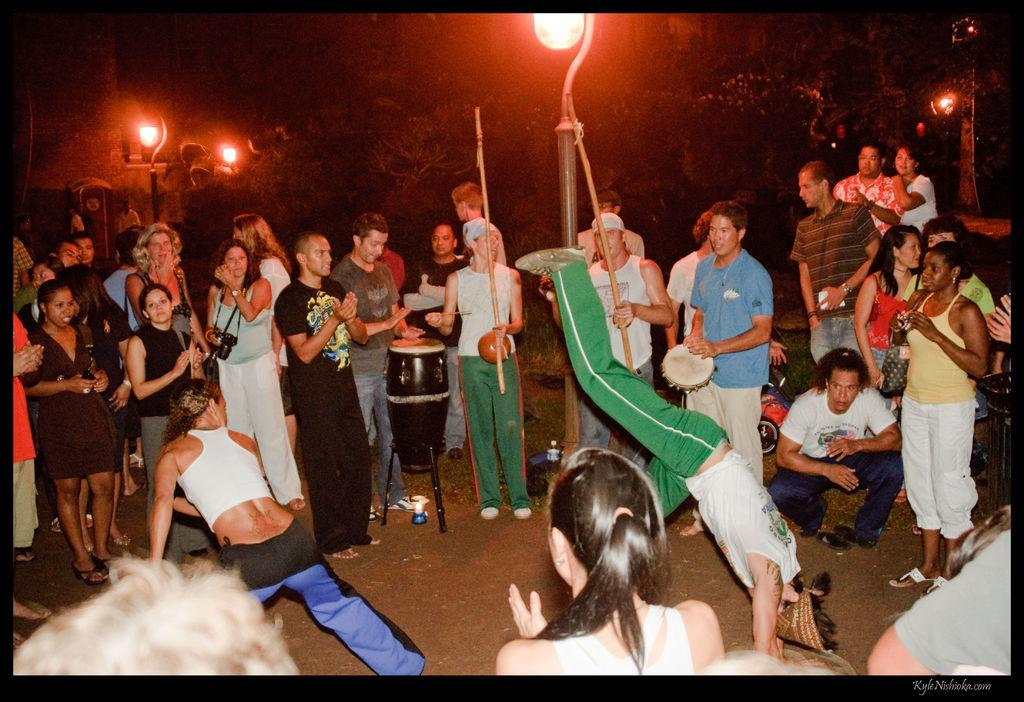How many people are in the image? There are people in the image, but the exact number is not specified. What are some of the people doing in the image? Some people are playing musical instruments in the image. What type of surface is visible in the image? There is ground visible in the image. What structures can be seen in the image? There are poles and lights in the image. What type of vegetation is present in the image? There are trees in the image. Can you describe the ground in the image? The ground is visible in the image. What type of muscle can be seen flexing in the image? There is no muscle flexing visible in the image. Can you describe the fish swimming in the image? There are no fish present in the image. 